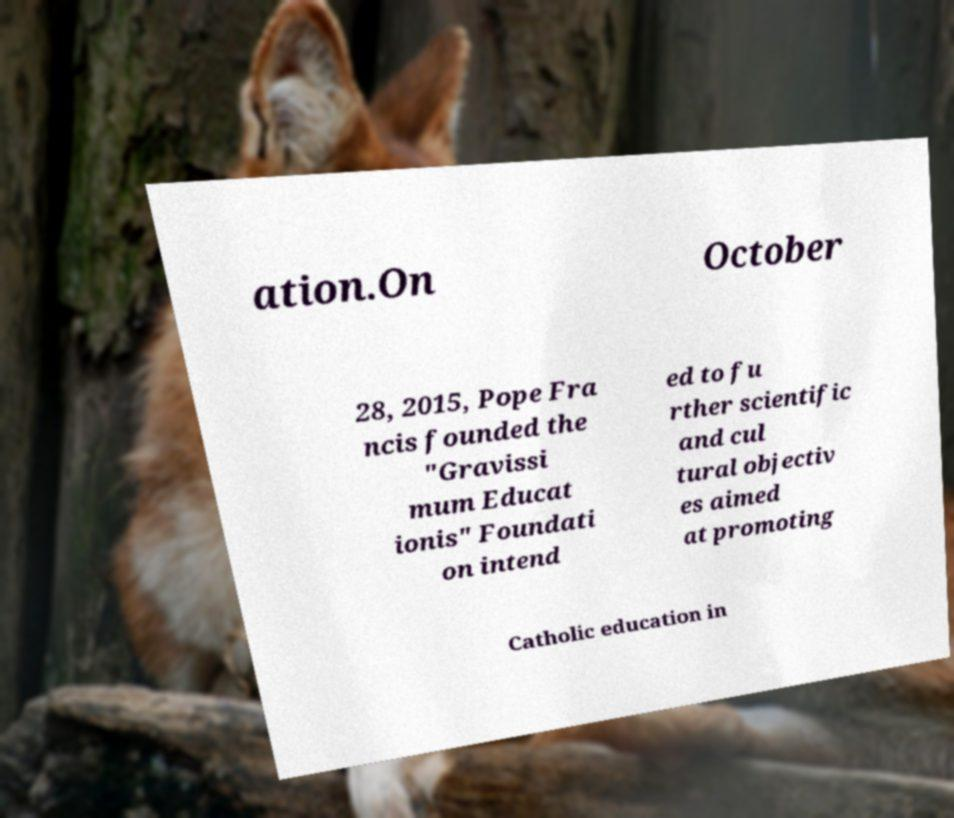Could you assist in decoding the text presented in this image and type it out clearly? ation.On October 28, 2015, Pope Fra ncis founded the "Gravissi mum Educat ionis" Foundati on intend ed to fu rther scientific and cul tural objectiv es aimed at promoting Catholic education in 